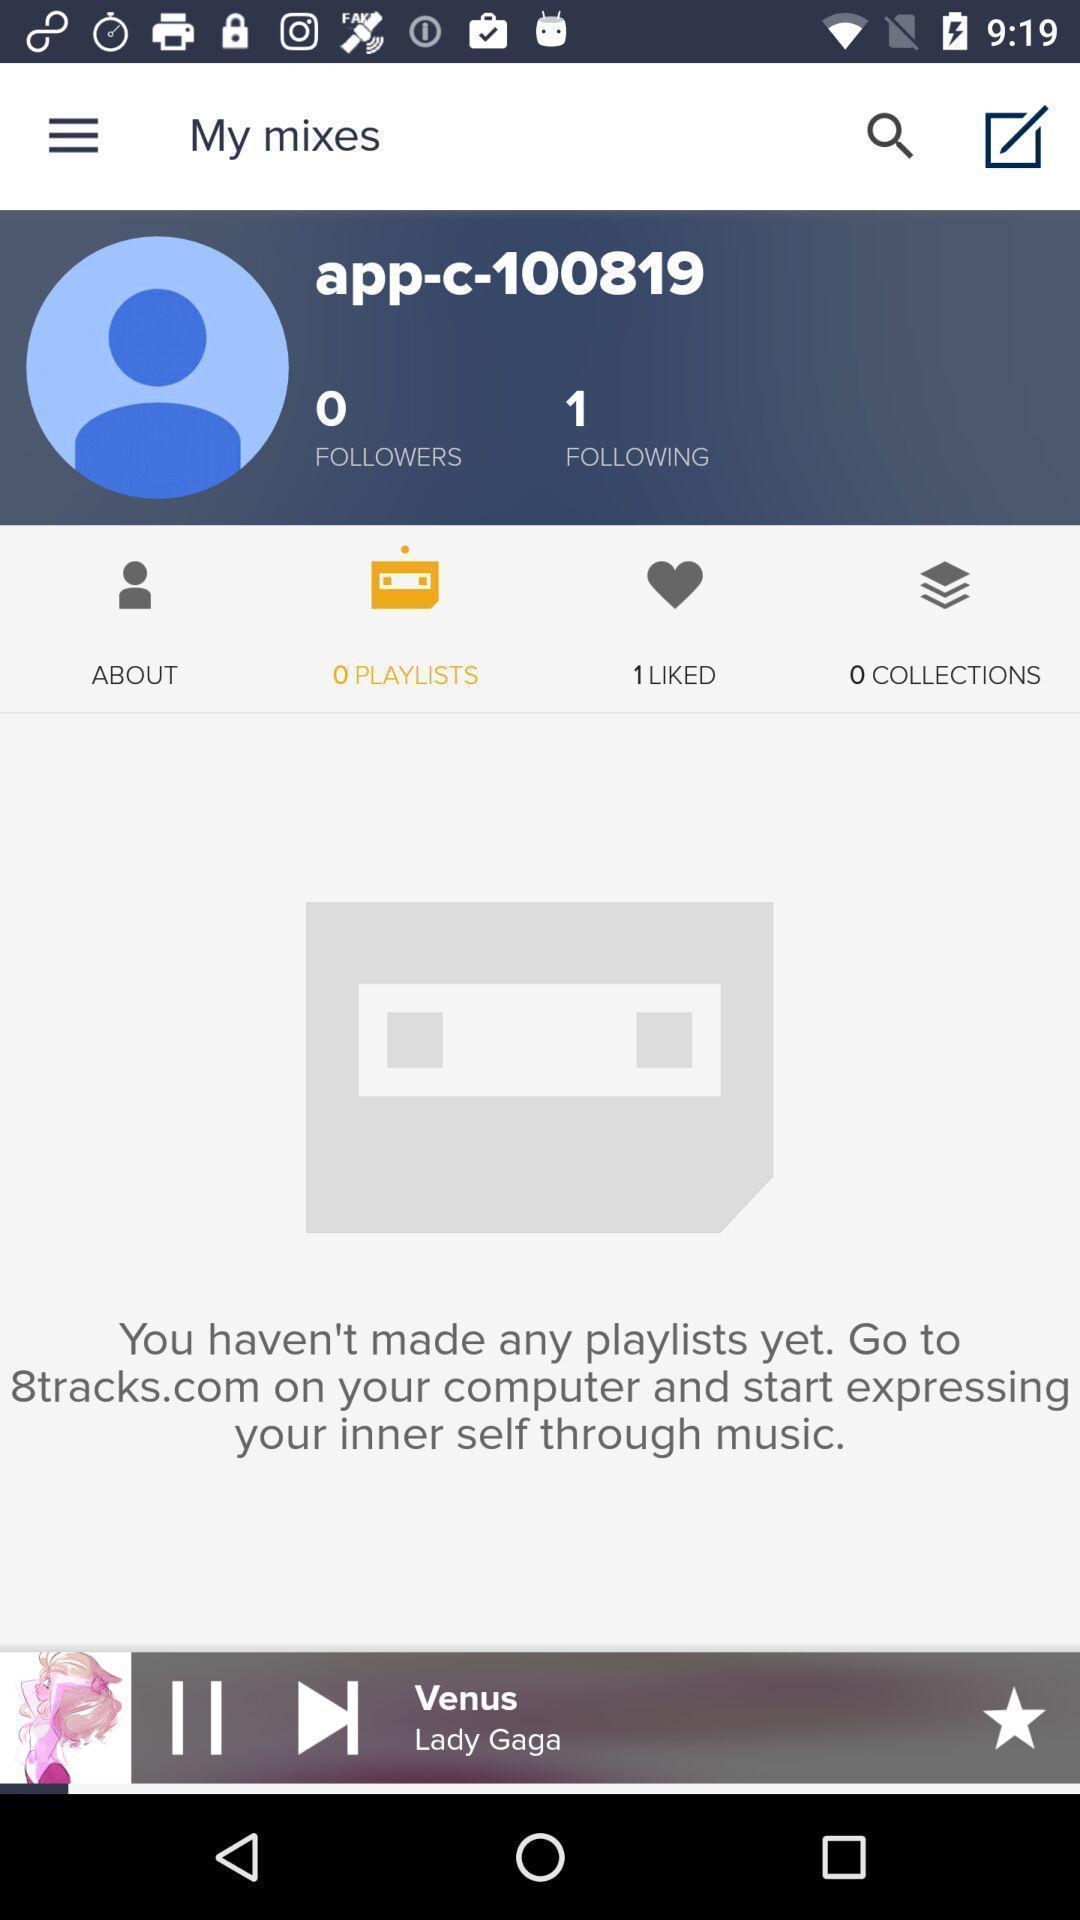Describe this image in words. Screen showing page of an music application. 